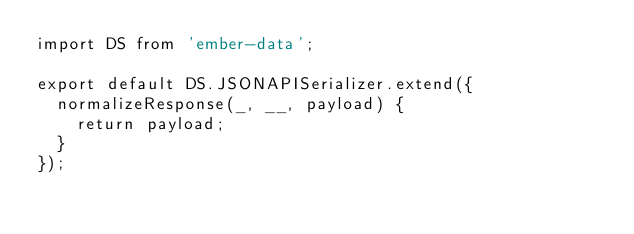<code> <loc_0><loc_0><loc_500><loc_500><_JavaScript_>import DS from 'ember-data';

export default DS.JSONAPISerializer.extend({
  normalizeResponse(_, __, payload) {
    return payload;
  }
});
</code> 